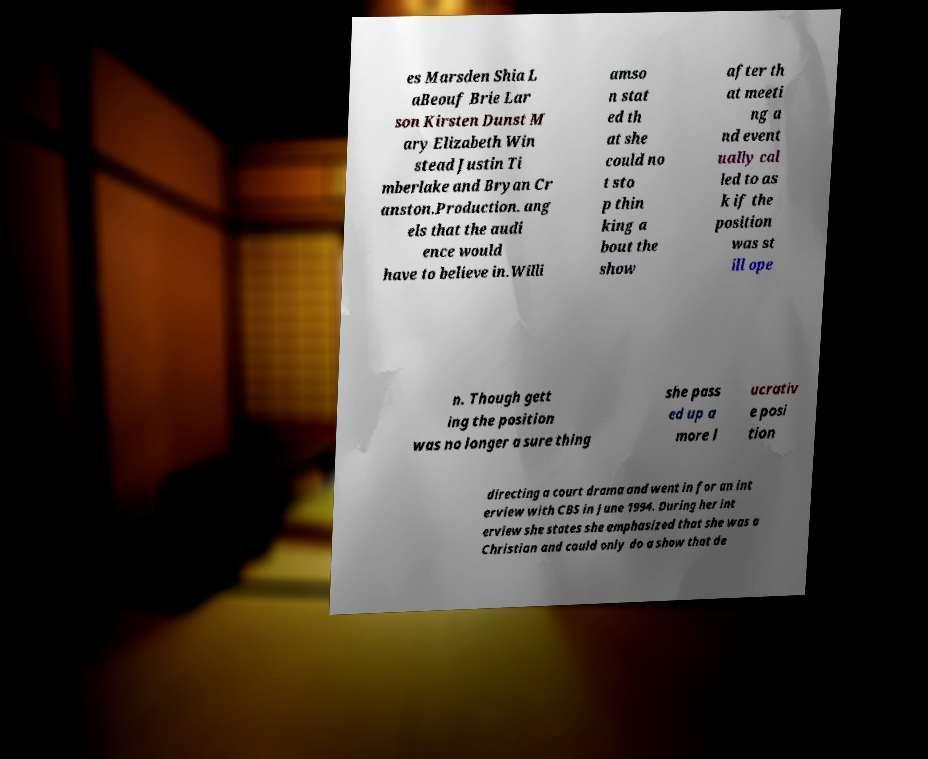Please read and relay the text visible in this image. What does it say? es Marsden Shia L aBeouf Brie Lar son Kirsten Dunst M ary Elizabeth Win stead Justin Ti mberlake and Bryan Cr anston.Production. ang els that the audi ence would have to believe in.Willi amso n stat ed th at she could no t sto p thin king a bout the show after th at meeti ng a nd event ually cal led to as k if the position was st ill ope n. Though gett ing the position was no longer a sure thing she pass ed up a more l ucrativ e posi tion directing a court drama and went in for an int erview with CBS in June 1994. During her int erview she states she emphasized that she was a Christian and could only do a show that de 